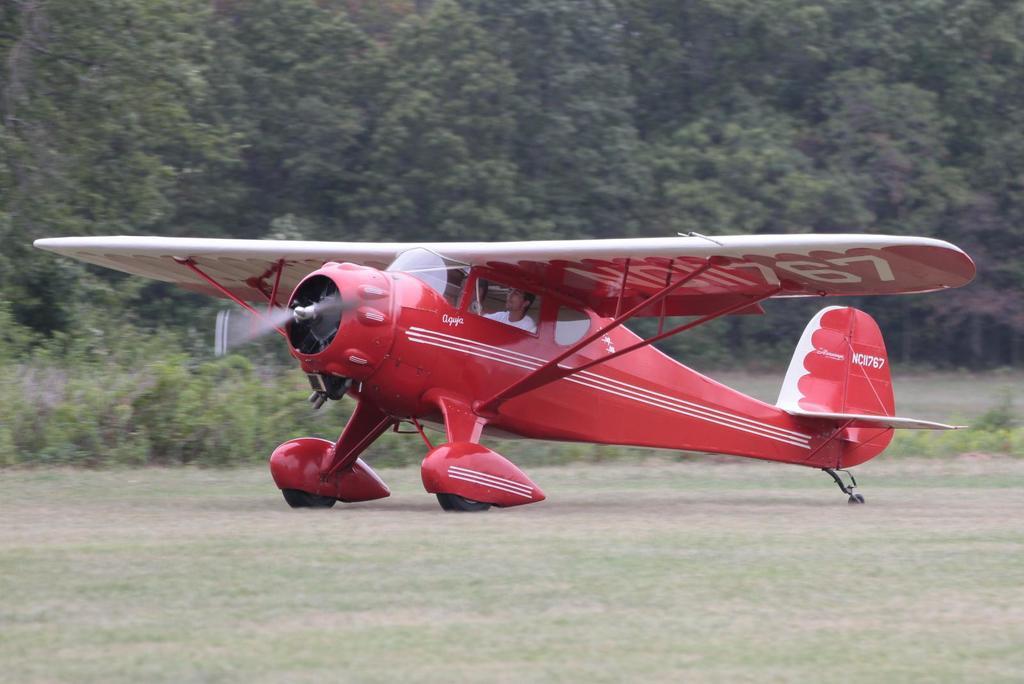Can you describe this image briefly? In this image there is an airplane on the grassland having plants. A person is sitting in the airplane. Background there are trees. 